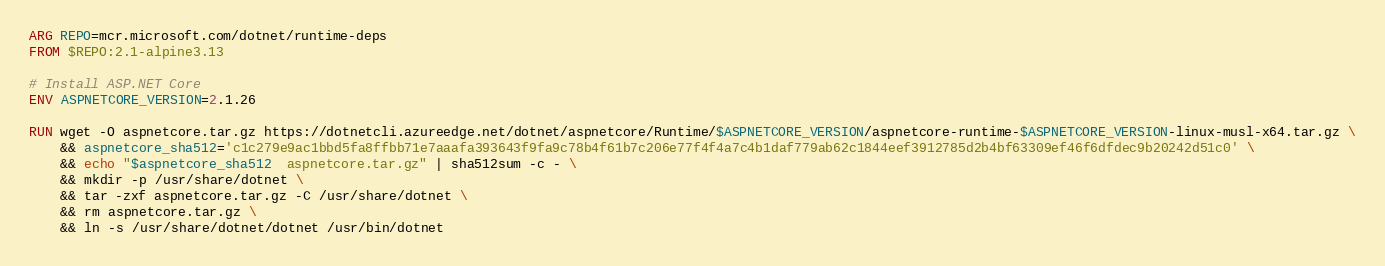Convert code to text. <code><loc_0><loc_0><loc_500><loc_500><_Dockerfile_>ARG REPO=mcr.microsoft.com/dotnet/runtime-deps
FROM $REPO:2.1-alpine3.13

# Install ASP.NET Core
ENV ASPNETCORE_VERSION=2.1.26

RUN wget -O aspnetcore.tar.gz https://dotnetcli.azureedge.net/dotnet/aspnetcore/Runtime/$ASPNETCORE_VERSION/aspnetcore-runtime-$ASPNETCORE_VERSION-linux-musl-x64.tar.gz \
    && aspnetcore_sha512='c1c279e9ac1bbd5fa8ffbb71e7aaafa393643f9fa9c78b4f61b7c206e77f4f4a7c4b1daf779ab62c1844eef3912785d2b4bf63309ef46f6dfdec9b20242d51c0' \
    && echo "$aspnetcore_sha512  aspnetcore.tar.gz" | sha512sum -c - \
    && mkdir -p /usr/share/dotnet \
    && tar -zxf aspnetcore.tar.gz -C /usr/share/dotnet \
    && rm aspnetcore.tar.gz \
    && ln -s /usr/share/dotnet/dotnet /usr/bin/dotnet
</code> 